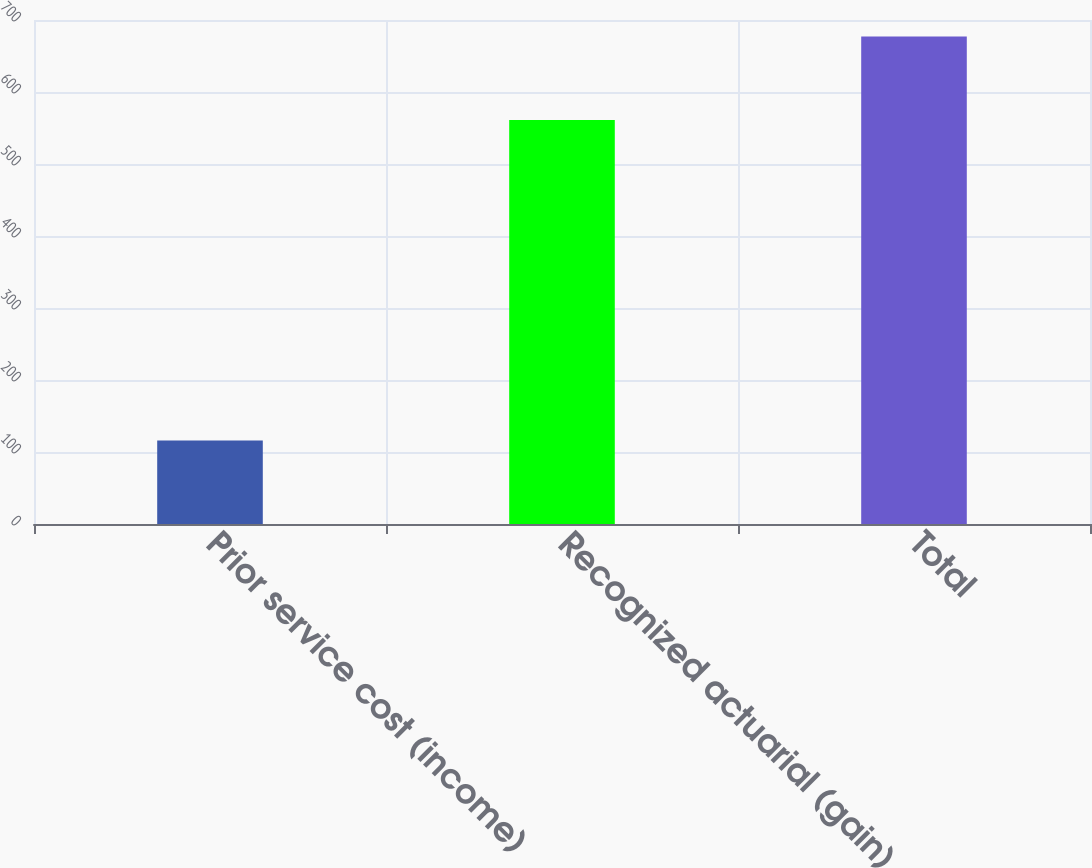Convert chart to OTSL. <chart><loc_0><loc_0><loc_500><loc_500><bar_chart><fcel>Prior service cost (income)<fcel>Recognized actuarial (gain)<fcel>Total<nl><fcel>116<fcel>561<fcel>677<nl></chart> 